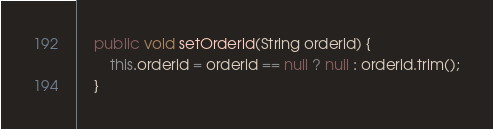Convert code to text. <code><loc_0><loc_0><loc_500><loc_500><_Java_>    public void setOrderid(String orderid) {
        this.orderid = orderid == null ? null : orderid.trim();
    }
</code> 